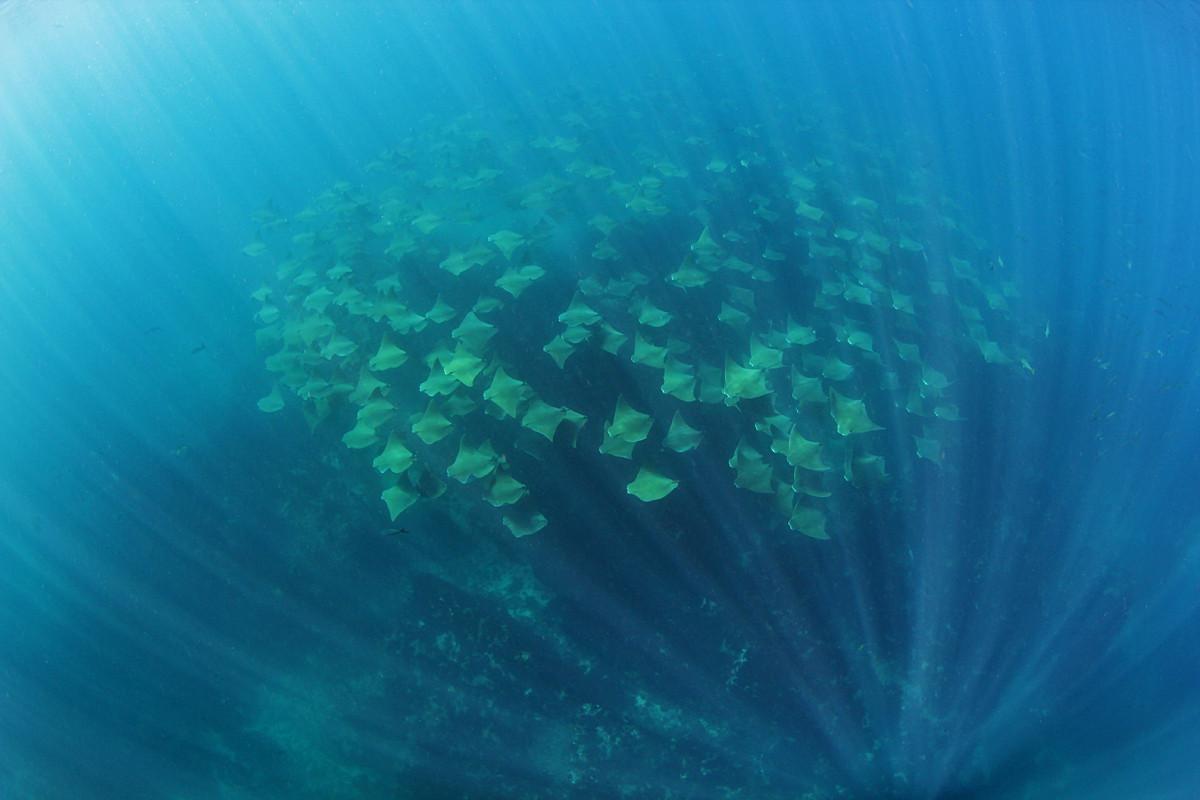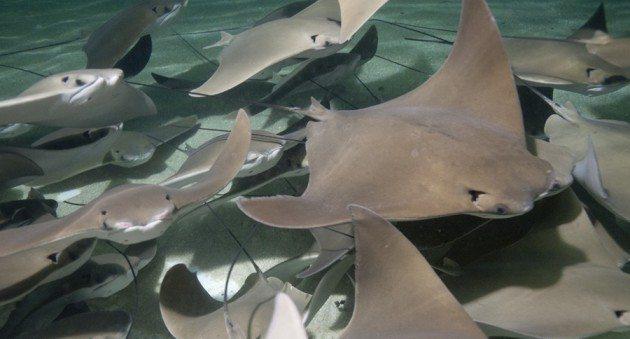The first image is the image on the left, the second image is the image on the right. Evaluate the accuracy of this statement regarding the images: "One of the images contains exactly one stingray.". Is it true? Answer yes or no. No. The first image is the image on the left, the second image is the image on the right. Examine the images to the left and right. Is the description "One stingray with a spotted pattern is included in the right image." accurate? Answer yes or no. No. 